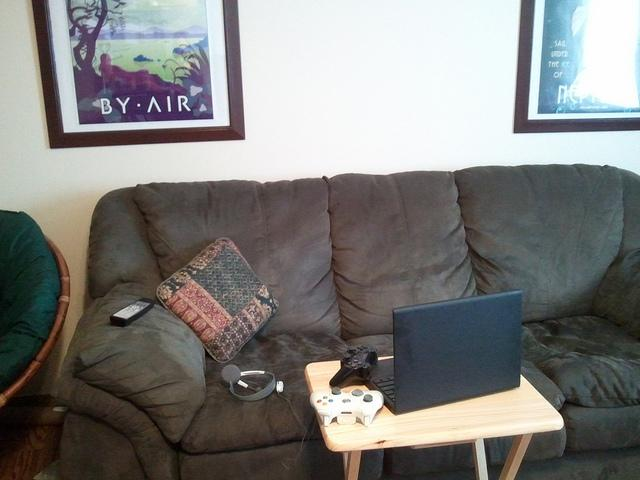Which gaming system is the white remote for on the table? xbox 